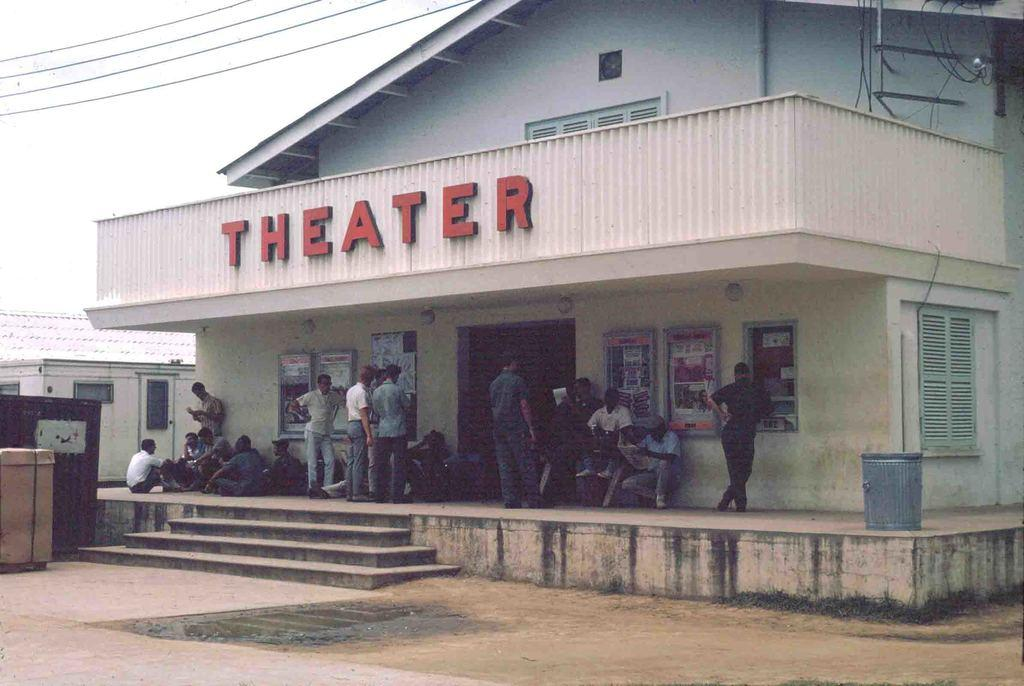How are the people in the image positioned? Some people are standing, while others are sitting. What type of structures can be seen in the image? There are buildings in the image. What are the boards used for in the image? The purpose of the boards in the image is not specified. What type of infrastructure is visible in the image? Cables are visible in the image. What else can be seen in the image besides the people, buildings, boards, and cables? There are other unspecified objects in the image. What is visible in the background of the image? The sky is visible in the background of the image. What month is it in the image? The month is not specified in the image. Can you see a wren in the image? There is no wren present in the image. 